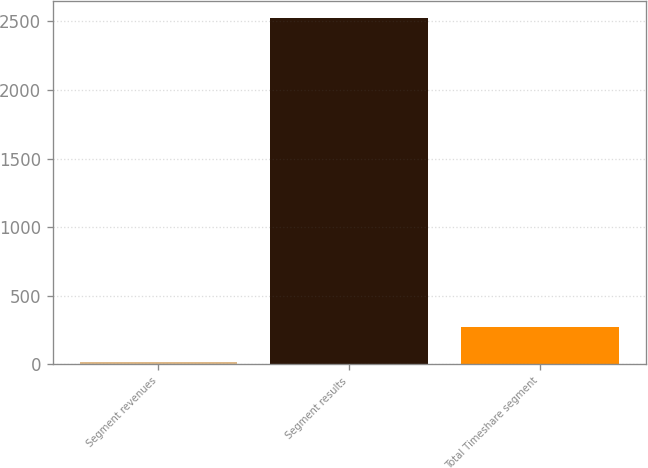<chart> <loc_0><loc_0><loc_500><loc_500><bar_chart><fcel>Segment revenues<fcel>Segment results<fcel>Total Timeshare segment<nl><fcel>18<fcel>2525<fcel>268.7<nl></chart> 